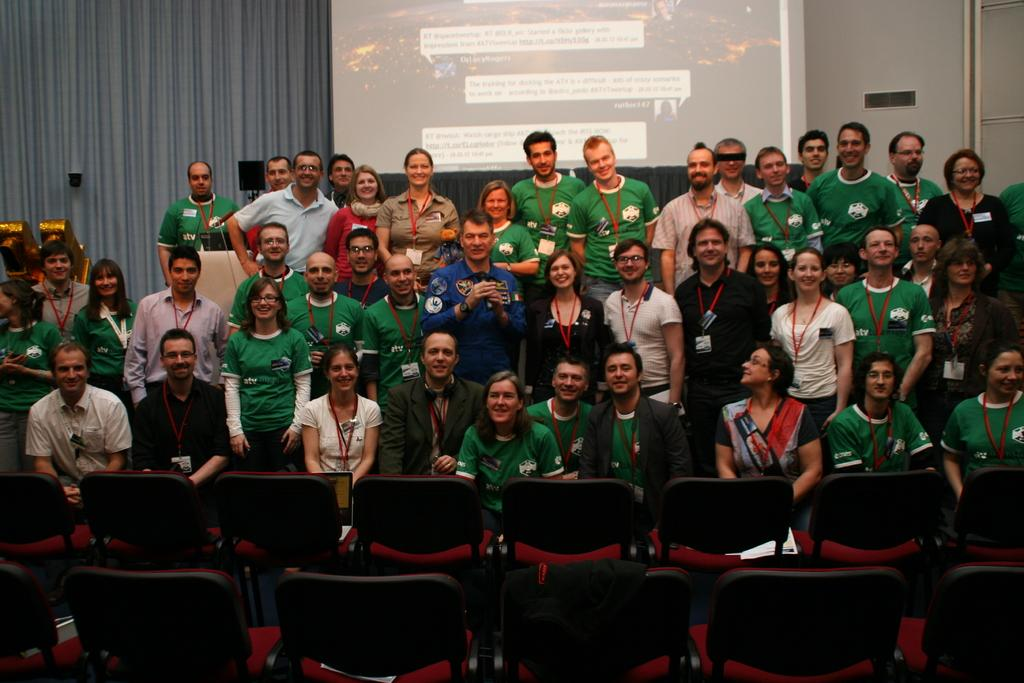What type of furniture is present in the image? There are chairs in the image. What are the people in the chairs doing? There are people sitting in the chairs. Are there any other people in the image besides those sitting? Yes, there are people standing in the image. What can be seen in the background of the image? There is a wall in the background of the image. How many cables are connected to the queen in the image? There is no queen or cables present in the image. 